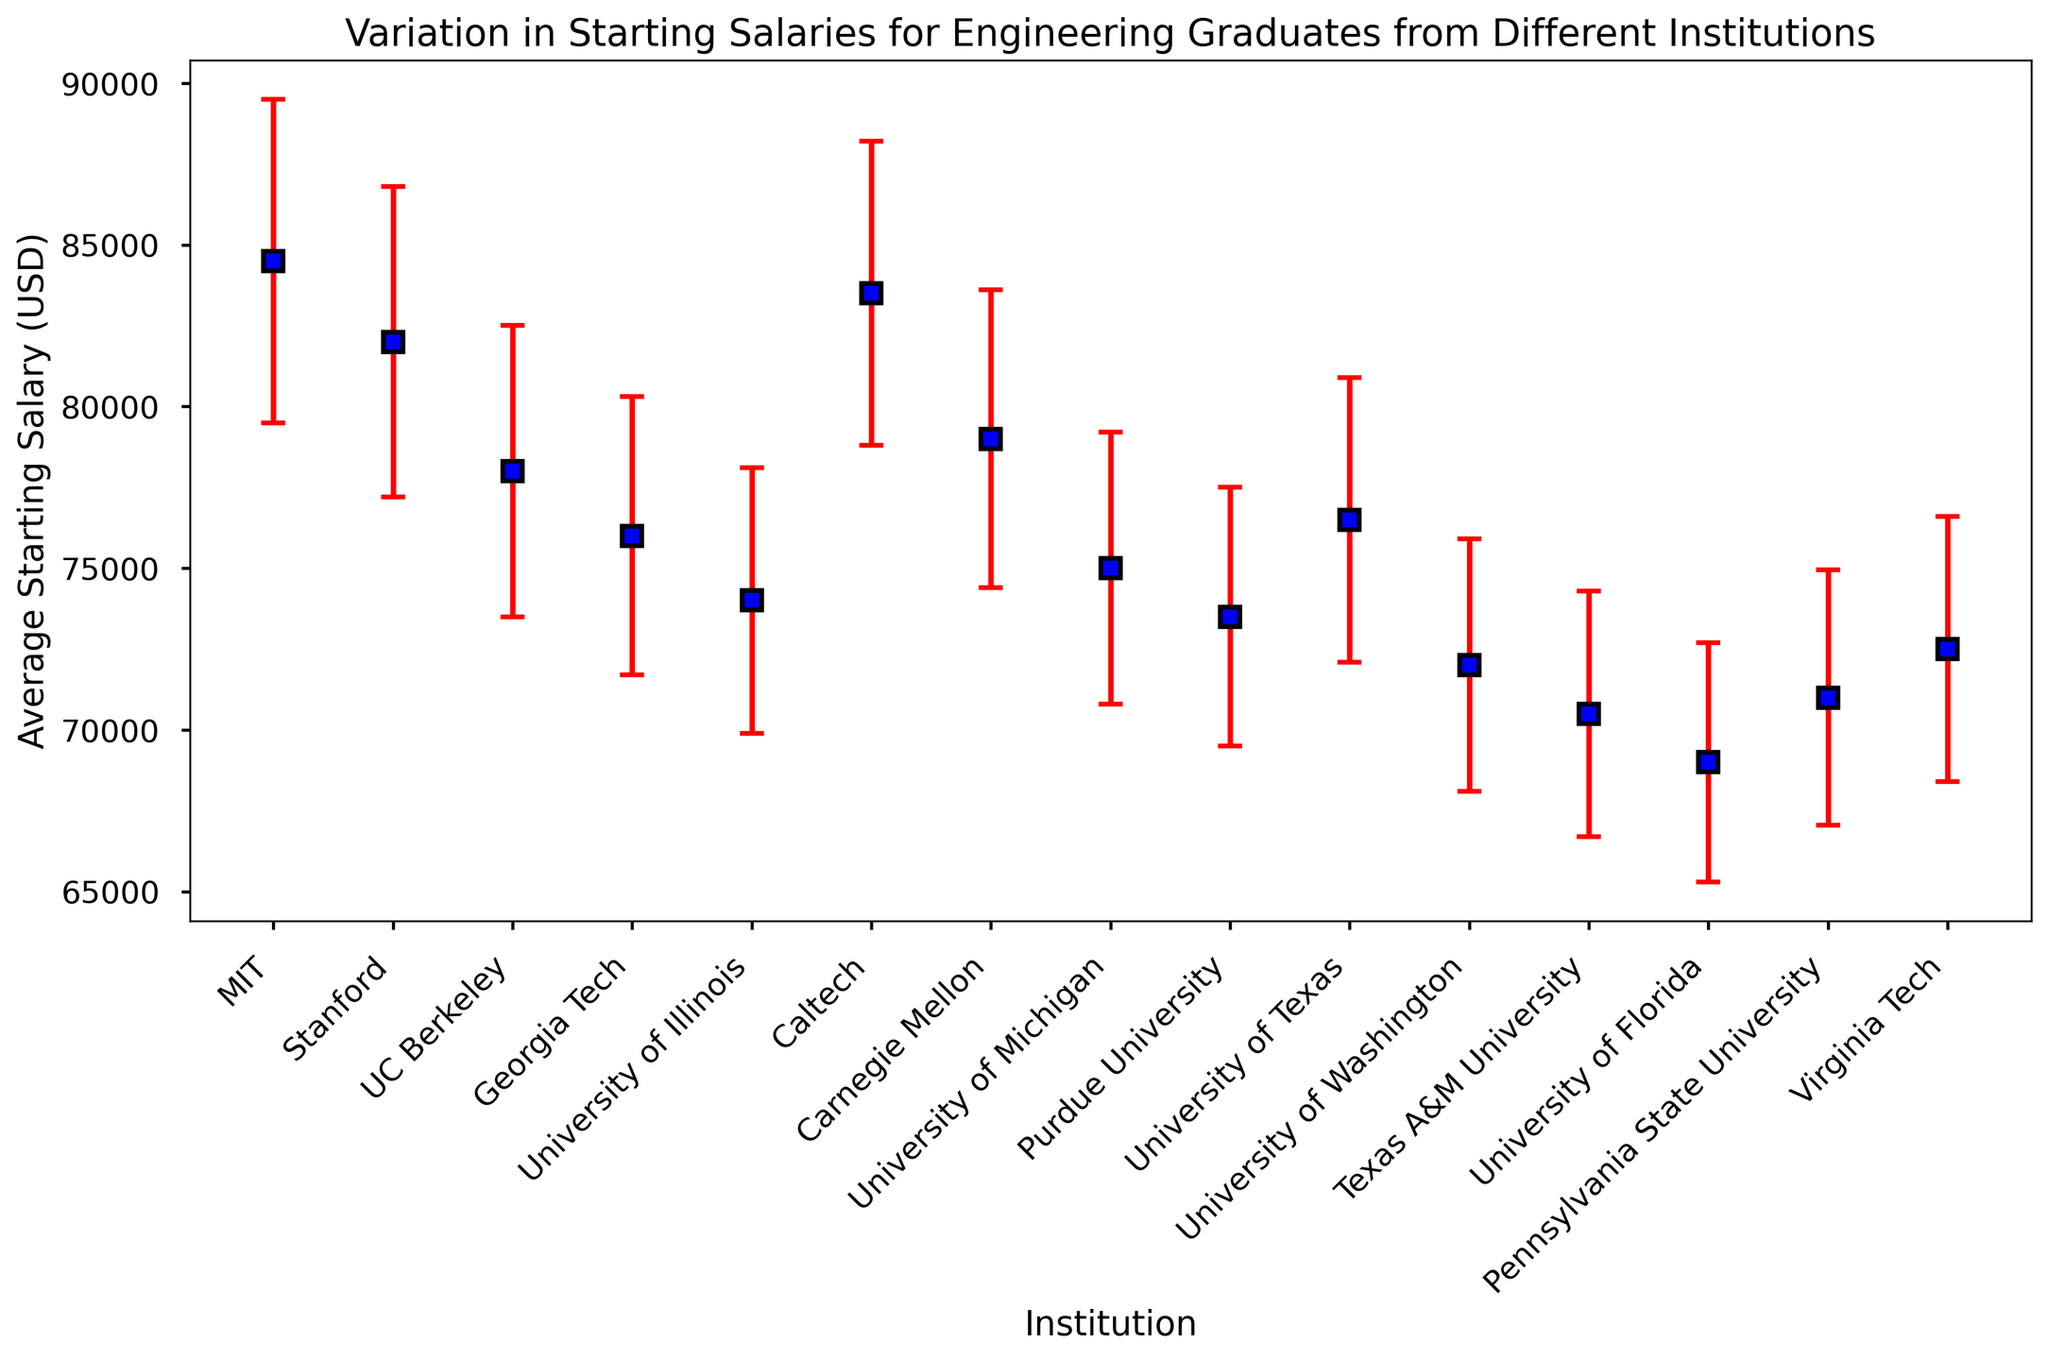what is the standard deviation for Caltech? Locate Caltech on the x-axis. The y-error bar corresponding to Caltech shows the standard deviation. The figure provides a standard deviation of 4700 for Caltech.
Answer: 4700 Which institution has the highest average starting salary, and what is the value? Identify which data point is the highest on the y-axis. The figure indicates that MIT has the highest average starting salary of 84500 USD.
Answer: MIT, 84500 USD How much lower is Georgia Tech's average starting salary compared to MIT? Locate MIT and Georgia Tech on the x-axis and note their average starting salaries. Subtract Georgia Tech's value (76000) from MIT's value (84500) to find the difference. The calculation is 84500 - 76000 = 8500 USD.
Answer: 8500 USD Which institution has the smallest standard deviation, and what is the value? Identify the data point associated with the shortest error bar. The figure shows Texas A&M University with the smallest standard deviation of 3800.
Answer: Texas A&M University, 3800 What is the visual attribute of the markers used to represent the institutions in the plot? Observe the graphical representation of the data points. The markers are square-shaped, have line edges, and are colored blue with black borders.
Answer: square-shaped, blue with black borders What is the average starting salary for Penn State University, and how does it compare to the University of Texas? Locate Penn State University and the University of Texas on the x-axis and note their average starting salaries. Penn State's average is 71000, while the University of Texas's average is 76500. Subtract 71000 from 76500 to get the difference, 76500 - 71000 = 5500 USD, with Texas having the higher amount.
Answer: 71000 USD, 5500 USD higher for Texas What is the range of average starting salaries shown in the figure? Identify the highest and lowest data points on the y-axis. The highest average starting salary is MIT's 84500 USD, and the lowest is the University of Florida's 69000 USD. Subtract 69000 from 84500 to get the range, 84500 - 69000 = 15500 USD.
Answer: 15500 USD Which institutions have average starting salaries above 80000 USD but below 85000 USD? Identify the data points on the y-axis between 80000 USD and 85000 USD. The institutions in this range include Stanford, Caltech, and MIT.
Answer: Stanford, Caltech How does the standard deviation for UC Berkeley compare to Carnegie Mellon? Locate UC Berkeley and Carnegie Mellon on the x-axis and note their standard deviations. UC Berkeley has a standard deviation of 4500, and Carnegie Mellon has 4600. Subtract 4500 from 4600, showing a difference of 100.
Answer: UC Berkeley has 100 less 